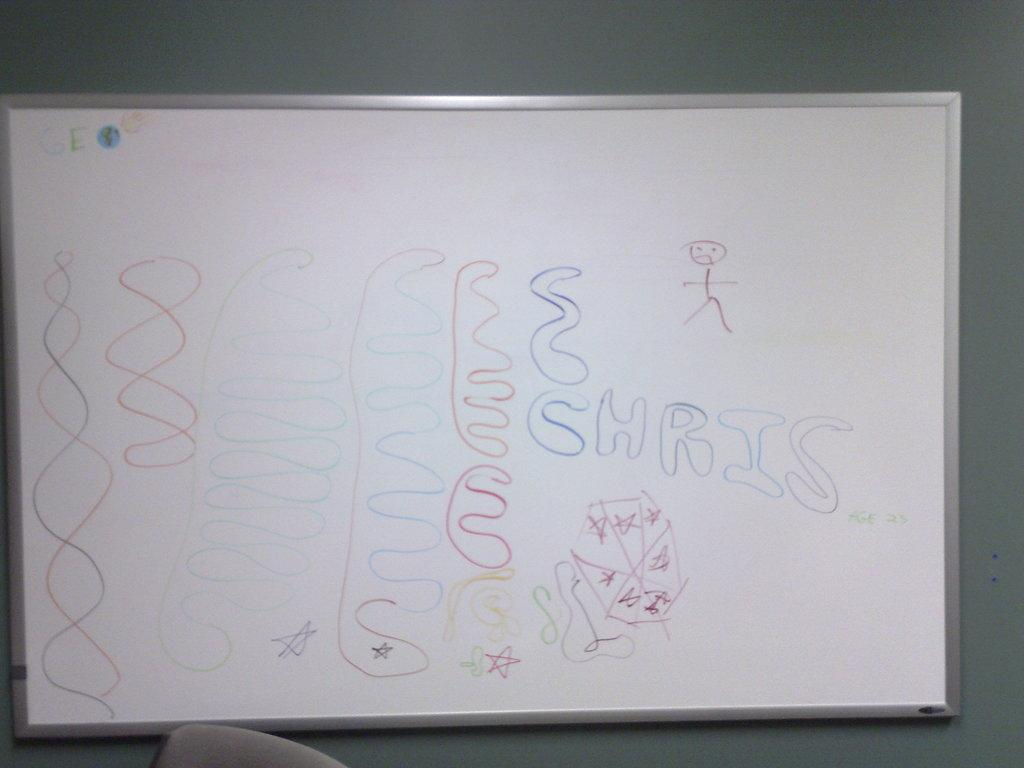<image>
Create a compact narrative representing the image presented. A classroom white board with colorful, squiggly lines drawn on it and the name Chris. 